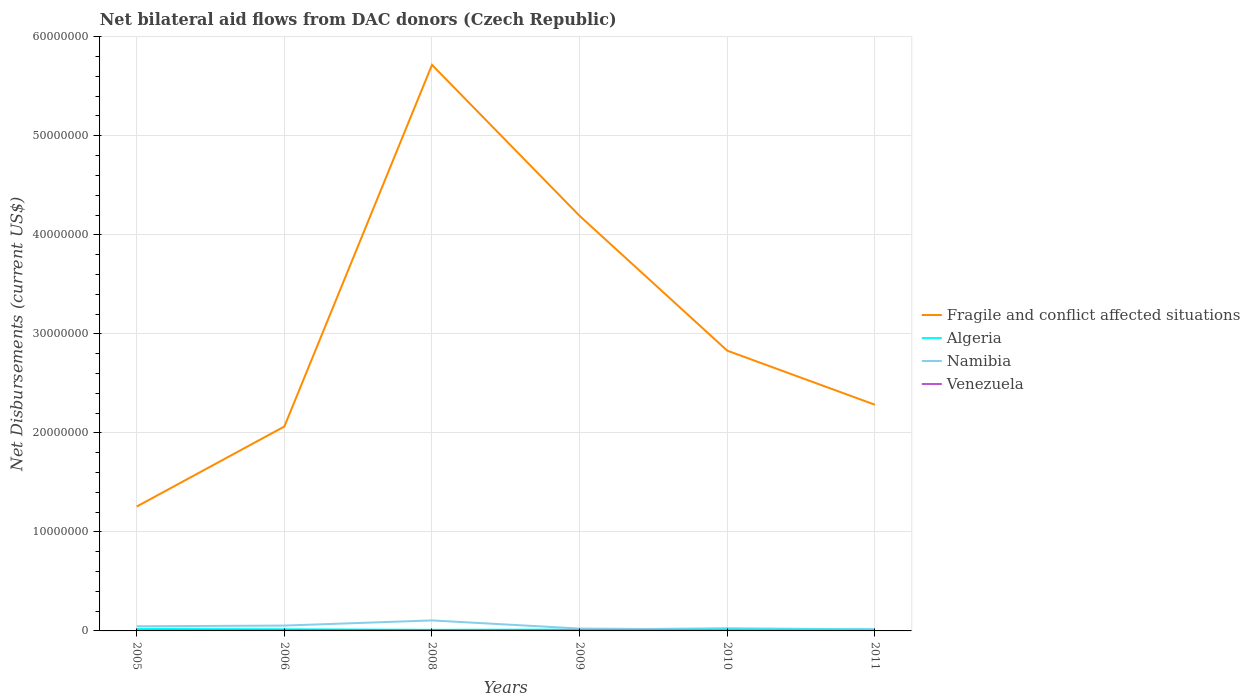How many different coloured lines are there?
Offer a terse response. 4. Across all years, what is the maximum net bilateral aid flows in Namibia?
Ensure brevity in your answer.  1.40e+05. What is the total net bilateral aid flows in Fragile and conflict affected situations in the graph?
Ensure brevity in your answer.  3.43e+07. What is the difference between the highest and the second highest net bilateral aid flows in Fragile and conflict affected situations?
Make the answer very short. 4.46e+07. What is the difference between the highest and the lowest net bilateral aid flows in Algeria?
Your answer should be compact. 2. Is the net bilateral aid flows in Venezuela strictly greater than the net bilateral aid flows in Namibia over the years?
Give a very brief answer. Yes. How many lines are there?
Offer a very short reply. 4. What is the difference between two consecutive major ticks on the Y-axis?
Your answer should be compact. 1.00e+07. Are the values on the major ticks of Y-axis written in scientific E-notation?
Keep it short and to the point. No. Does the graph contain grids?
Provide a short and direct response. Yes. How are the legend labels stacked?
Ensure brevity in your answer.  Vertical. What is the title of the graph?
Make the answer very short. Net bilateral aid flows from DAC donors (Czech Republic). Does "Italy" appear as one of the legend labels in the graph?
Give a very brief answer. No. What is the label or title of the Y-axis?
Give a very brief answer. Net Disbursements (current US$). What is the Net Disbursements (current US$) of Fragile and conflict affected situations in 2005?
Offer a very short reply. 1.26e+07. What is the Net Disbursements (current US$) of Namibia in 2005?
Make the answer very short. 4.70e+05. What is the Net Disbursements (current US$) of Venezuela in 2005?
Provide a short and direct response. 3.00e+04. What is the Net Disbursements (current US$) of Fragile and conflict affected situations in 2006?
Provide a short and direct response. 2.06e+07. What is the Net Disbursements (current US$) of Algeria in 2006?
Make the answer very short. 1.70e+05. What is the Net Disbursements (current US$) of Namibia in 2006?
Ensure brevity in your answer.  5.40e+05. What is the Net Disbursements (current US$) of Venezuela in 2006?
Offer a terse response. 6.00e+04. What is the Net Disbursements (current US$) of Fragile and conflict affected situations in 2008?
Provide a short and direct response. 5.72e+07. What is the Net Disbursements (current US$) in Namibia in 2008?
Keep it short and to the point. 1.06e+06. What is the Net Disbursements (current US$) in Fragile and conflict affected situations in 2009?
Give a very brief answer. 4.19e+07. What is the Net Disbursements (current US$) of Namibia in 2009?
Provide a short and direct response. 2.40e+05. What is the Net Disbursements (current US$) of Fragile and conflict affected situations in 2010?
Offer a very short reply. 2.83e+07. What is the Net Disbursements (current US$) of Fragile and conflict affected situations in 2011?
Offer a terse response. 2.28e+07. What is the Net Disbursements (current US$) of Algeria in 2011?
Make the answer very short. 1.60e+05. Across all years, what is the maximum Net Disbursements (current US$) of Fragile and conflict affected situations?
Your answer should be compact. 5.72e+07. Across all years, what is the maximum Net Disbursements (current US$) in Namibia?
Ensure brevity in your answer.  1.06e+06. Across all years, what is the minimum Net Disbursements (current US$) in Fragile and conflict affected situations?
Your answer should be compact. 1.26e+07. Across all years, what is the minimum Net Disbursements (current US$) in Algeria?
Offer a terse response. 1.10e+05. Across all years, what is the minimum Net Disbursements (current US$) of Namibia?
Give a very brief answer. 1.40e+05. What is the total Net Disbursements (current US$) in Fragile and conflict affected situations in the graph?
Keep it short and to the point. 1.83e+08. What is the total Net Disbursements (current US$) of Algeria in the graph?
Your answer should be compact. 1.04e+06. What is the total Net Disbursements (current US$) of Namibia in the graph?
Give a very brief answer. 2.61e+06. What is the total Net Disbursements (current US$) in Venezuela in the graph?
Offer a terse response. 2.70e+05. What is the difference between the Net Disbursements (current US$) of Fragile and conflict affected situations in 2005 and that in 2006?
Offer a terse response. -8.08e+06. What is the difference between the Net Disbursements (current US$) of Algeria in 2005 and that in 2006?
Ensure brevity in your answer.  3.00e+04. What is the difference between the Net Disbursements (current US$) in Fragile and conflict affected situations in 2005 and that in 2008?
Provide a short and direct response. -4.46e+07. What is the difference between the Net Disbursements (current US$) in Namibia in 2005 and that in 2008?
Your response must be concise. -5.90e+05. What is the difference between the Net Disbursements (current US$) in Venezuela in 2005 and that in 2008?
Provide a short and direct response. -5.00e+04. What is the difference between the Net Disbursements (current US$) of Fragile and conflict affected situations in 2005 and that in 2009?
Make the answer very short. -2.94e+07. What is the difference between the Net Disbursements (current US$) of Venezuela in 2005 and that in 2009?
Ensure brevity in your answer.  -2.00e+04. What is the difference between the Net Disbursements (current US$) of Fragile and conflict affected situations in 2005 and that in 2010?
Offer a very short reply. -1.57e+07. What is the difference between the Net Disbursements (current US$) of Algeria in 2005 and that in 2010?
Offer a terse response. -6.00e+04. What is the difference between the Net Disbursements (current US$) of Fragile and conflict affected situations in 2005 and that in 2011?
Your answer should be very brief. -1.03e+07. What is the difference between the Net Disbursements (current US$) in Algeria in 2005 and that in 2011?
Keep it short and to the point. 4.00e+04. What is the difference between the Net Disbursements (current US$) of Fragile and conflict affected situations in 2006 and that in 2008?
Provide a succinct answer. -3.65e+07. What is the difference between the Net Disbursements (current US$) in Algeria in 2006 and that in 2008?
Keep it short and to the point. 6.00e+04. What is the difference between the Net Disbursements (current US$) of Namibia in 2006 and that in 2008?
Make the answer very short. -5.20e+05. What is the difference between the Net Disbursements (current US$) of Venezuela in 2006 and that in 2008?
Give a very brief answer. -2.00e+04. What is the difference between the Net Disbursements (current US$) of Fragile and conflict affected situations in 2006 and that in 2009?
Provide a short and direct response. -2.13e+07. What is the difference between the Net Disbursements (current US$) in Venezuela in 2006 and that in 2009?
Offer a terse response. 10000. What is the difference between the Net Disbursements (current US$) in Fragile and conflict affected situations in 2006 and that in 2010?
Keep it short and to the point. -7.66e+06. What is the difference between the Net Disbursements (current US$) in Fragile and conflict affected situations in 2006 and that in 2011?
Provide a short and direct response. -2.20e+06. What is the difference between the Net Disbursements (current US$) in Namibia in 2006 and that in 2011?
Provide a short and direct response. 3.80e+05. What is the difference between the Net Disbursements (current US$) in Venezuela in 2006 and that in 2011?
Make the answer very short. 5.00e+04. What is the difference between the Net Disbursements (current US$) of Fragile and conflict affected situations in 2008 and that in 2009?
Provide a succinct answer. 1.52e+07. What is the difference between the Net Disbursements (current US$) of Algeria in 2008 and that in 2009?
Provide a succinct answer. -3.00e+04. What is the difference between the Net Disbursements (current US$) in Namibia in 2008 and that in 2009?
Ensure brevity in your answer.  8.20e+05. What is the difference between the Net Disbursements (current US$) of Venezuela in 2008 and that in 2009?
Provide a short and direct response. 3.00e+04. What is the difference between the Net Disbursements (current US$) of Fragile and conflict affected situations in 2008 and that in 2010?
Ensure brevity in your answer.  2.89e+07. What is the difference between the Net Disbursements (current US$) of Algeria in 2008 and that in 2010?
Keep it short and to the point. -1.50e+05. What is the difference between the Net Disbursements (current US$) of Namibia in 2008 and that in 2010?
Your answer should be compact. 9.20e+05. What is the difference between the Net Disbursements (current US$) of Fragile and conflict affected situations in 2008 and that in 2011?
Provide a succinct answer. 3.43e+07. What is the difference between the Net Disbursements (current US$) of Namibia in 2008 and that in 2011?
Your response must be concise. 9.00e+05. What is the difference between the Net Disbursements (current US$) of Fragile and conflict affected situations in 2009 and that in 2010?
Your answer should be compact. 1.36e+07. What is the difference between the Net Disbursements (current US$) in Namibia in 2009 and that in 2010?
Offer a terse response. 1.00e+05. What is the difference between the Net Disbursements (current US$) in Venezuela in 2009 and that in 2010?
Offer a very short reply. 10000. What is the difference between the Net Disbursements (current US$) of Fragile and conflict affected situations in 2009 and that in 2011?
Ensure brevity in your answer.  1.91e+07. What is the difference between the Net Disbursements (current US$) in Algeria in 2009 and that in 2011?
Offer a terse response. -2.00e+04. What is the difference between the Net Disbursements (current US$) of Fragile and conflict affected situations in 2010 and that in 2011?
Ensure brevity in your answer.  5.46e+06. What is the difference between the Net Disbursements (current US$) of Venezuela in 2010 and that in 2011?
Make the answer very short. 3.00e+04. What is the difference between the Net Disbursements (current US$) in Fragile and conflict affected situations in 2005 and the Net Disbursements (current US$) in Algeria in 2006?
Provide a short and direct response. 1.24e+07. What is the difference between the Net Disbursements (current US$) of Fragile and conflict affected situations in 2005 and the Net Disbursements (current US$) of Namibia in 2006?
Your answer should be very brief. 1.20e+07. What is the difference between the Net Disbursements (current US$) of Fragile and conflict affected situations in 2005 and the Net Disbursements (current US$) of Venezuela in 2006?
Ensure brevity in your answer.  1.25e+07. What is the difference between the Net Disbursements (current US$) of Algeria in 2005 and the Net Disbursements (current US$) of Namibia in 2006?
Ensure brevity in your answer.  -3.40e+05. What is the difference between the Net Disbursements (current US$) in Namibia in 2005 and the Net Disbursements (current US$) in Venezuela in 2006?
Give a very brief answer. 4.10e+05. What is the difference between the Net Disbursements (current US$) of Fragile and conflict affected situations in 2005 and the Net Disbursements (current US$) of Algeria in 2008?
Offer a very short reply. 1.24e+07. What is the difference between the Net Disbursements (current US$) in Fragile and conflict affected situations in 2005 and the Net Disbursements (current US$) in Namibia in 2008?
Make the answer very short. 1.15e+07. What is the difference between the Net Disbursements (current US$) of Fragile and conflict affected situations in 2005 and the Net Disbursements (current US$) of Venezuela in 2008?
Your answer should be compact. 1.25e+07. What is the difference between the Net Disbursements (current US$) in Algeria in 2005 and the Net Disbursements (current US$) in Namibia in 2008?
Your response must be concise. -8.60e+05. What is the difference between the Net Disbursements (current US$) in Namibia in 2005 and the Net Disbursements (current US$) in Venezuela in 2008?
Your response must be concise. 3.90e+05. What is the difference between the Net Disbursements (current US$) in Fragile and conflict affected situations in 2005 and the Net Disbursements (current US$) in Algeria in 2009?
Provide a short and direct response. 1.24e+07. What is the difference between the Net Disbursements (current US$) in Fragile and conflict affected situations in 2005 and the Net Disbursements (current US$) in Namibia in 2009?
Give a very brief answer. 1.23e+07. What is the difference between the Net Disbursements (current US$) of Fragile and conflict affected situations in 2005 and the Net Disbursements (current US$) of Venezuela in 2009?
Provide a succinct answer. 1.25e+07. What is the difference between the Net Disbursements (current US$) in Algeria in 2005 and the Net Disbursements (current US$) in Namibia in 2009?
Your answer should be very brief. -4.00e+04. What is the difference between the Net Disbursements (current US$) of Fragile and conflict affected situations in 2005 and the Net Disbursements (current US$) of Algeria in 2010?
Your answer should be very brief. 1.23e+07. What is the difference between the Net Disbursements (current US$) of Fragile and conflict affected situations in 2005 and the Net Disbursements (current US$) of Namibia in 2010?
Make the answer very short. 1.24e+07. What is the difference between the Net Disbursements (current US$) in Fragile and conflict affected situations in 2005 and the Net Disbursements (current US$) in Venezuela in 2010?
Your answer should be compact. 1.25e+07. What is the difference between the Net Disbursements (current US$) of Algeria in 2005 and the Net Disbursements (current US$) of Venezuela in 2010?
Your answer should be compact. 1.60e+05. What is the difference between the Net Disbursements (current US$) in Namibia in 2005 and the Net Disbursements (current US$) in Venezuela in 2010?
Your answer should be very brief. 4.30e+05. What is the difference between the Net Disbursements (current US$) of Fragile and conflict affected situations in 2005 and the Net Disbursements (current US$) of Algeria in 2011?
Your response must be concise. 1.24e+07. What is the difference between the Net Disbursements (current US$) in Fragile and conflict affected situations in 2005 and the Net Disbursements (current US$) in Namibia in 2011?
Offer a terse response. 1.24e+07. What is the difference between the Net Disbursements (current US$) in Fragile and conflict affected situations in 2005 and the Net Disbursements (current US$) in Venezuela in 2011?
Provide a succinct answer. 1.26e+07. What is the difference between the Net Disbursements (current US$) in Algeria in 2005 and the Net Disbursements (current US$) in Venezuela in 2011?
Your response must be concise. 1.90e+05. What is the difference between the Net Disbursements (current US$) in Fragile and conflict affected situations in 2006 and the Net Disbursements (current US$) in Algeria in 2008?
Your response must be concise. 2.05e+07. What is the difference between the Net Disbursements (current US$) in Fragile and conflict affected situations in 2006 and the Net Disbursements (current US$) in Namibia in 2008?
Provide a succinct answer. 1.96e+07. What is the difference between the Net Disbursements (current US$) of Fragile and conflict affected situations in 2006 and the Net Disbursements (current US$) of Venezuela in 2008?
Your response must be concise. 2.06e+07. What is the difference between the Net Disbursements (current US$) of Algeria in 2006 and the Net Disbursements (current US$) of Namibia in 2008?
Give a very brief answer. -8.90e+05. What is the difference between the Net Disbursements (current US$) in Fragile and conflict affected situations in 2006 and the Net Disbursements (current US$) in Algeria in 2009?
Your answer should be compact. 2.05e+07. What is the difference between the Net Disbursements (current US$) of Fragile and conflict affected situations in 2006 and the Net Disbursements (current US$) of Namibia in 2009?
Your answer should be very brief. 2.04e+07. What is the difference between the Net Disbursements (current US$) in Fragile and conflict affected situations in 2006 and the Net Disbursements (current US$) in Venezuela in 2009?
Give a very brief answer. 2.06e+07. What is the difference between the Net Disbursements (current US$) of Algeria in 2006 and the Net Disbursements (current US$) of Namibia in 2009?
Provide a succinct answer. -7.00e+04. What is the difference between the Net Disbursements (current US$) of Algeria in 2006 and the Net Disbursements (current US$) of Venezuela in 2009?
Your response must be concise. 1.20e+05. What is the difference between the Net Disbursements (current US$) in Namibia in 2006 and the Net Disbursements (current US$) in Venezuela in 2009?
Offer a terse response. 4.90e+05. What is the difference between the Net Disbursements (current US$) of Fragile and conflict affected situations in 2006 and the Net Disbursements (current US$) of Algeria in 2010?
Ensure brevity in your answer.  2.04e+07. What is the difference between the Net Disbursements (current US$) of Fragile and conflict affected situations in 2006 and the Net Disbursements (current US$) of Namibia in 2010?
Keep it short and to the point. 2.05e+07. What is the difference between the Net Disbursements (current US$) of Fragile and conflict affected situations in 2006 and the Net Disbursements (current US$) of Venezuela in 2010?
Keep it short and to the point. 2.06e+07. What is the difference between the Net Disbursements (current US$) in Algeria in 2006 and the Net Disbursements (current US$) in Namibia in 2010?
Provide a succinct answer. 3.00e+04. What is the difference between the Net Disbursements (current US$) of Algeria in 2006 and the Net Disbursements (current US$) of Venezuela in 2010?
Ensure brevity in your answer.  1.30e+05. What is the difference between the Net Disbursements (current US$) of Fragile and conflict affected situations in 2006 and the Net Disbursements (current US$) of Algeria in 2011?
Your response must be concise. 2.05e+07. What is the difference between the Net Disbursements (current US$) of Fragile and conflict affected situations in 2006 and the Net Disbursements (current US$) of Namibia in 2011?
Provide a succinct answer. 2.05e+07. What is the difference between the Net Disbursements (current US$) in Fragile and conflict affected situations in 2006 and the Net Disbursements (current US$) in Venezuela in 2011?
Your answer should be compact. 2.06e+07. What is the difference between the Net Disbursements (current US$) of Algeria in 2006 and the Net Disbursements (current US$) of Namibia in 2011?
Offer a terse response. 10000. What is the difference between the Net Disbursements (current US$) in Namibia in 2006 and the Net Disbursements (current US$) in Venezuela in 2011?
Ensure brevity in your answer.  5.30e+05. What is the difference between the Net Disbursements (current US$) of Fragile and conflict affected situations in 2008 and the Net Disbursements (current US$) of Algeria in 2009?
Make the answer very short. 5.70e+07. What is the difference between the Net Disbursements (current US$) in Fragile and conflict affected situations in 2008 and the Net Disbursements (current US$) in Namibia in 2009?
Ensure brevity in your answer.  5.69e+07. What is the difference between the Net Disbursements (current US$) in Fragile and conflict affected situations in 2008 and the Net Disbursements (current US$) in Venezuela in 2009?
Provide a short and direct response. 5.71e+07. What is the difference between the Net Disbursements (current US$) of Algeria in 2008 and the Net Disbursements (current US$) of Namibia in 2009?
Make the answer very short. -1.30e+05. What is the difference between the Net Disbursements (current US$) of Namibia in 2008 and the Net Disbursements (current US$) of Venezuela in 2009?
Give a very brief answer. 1.01e+06. What is the difference between the Net Disbursements (current US$) in Fragile and conflict affected situations in 2008 and the Net Disbursements (current US$) in Algeria in 2010?
Ensure brevity in your answer.  5.69e+07. What is the difference between the Net Disbursements (current US$) of Fragile and conflict affected situations in 2008 and the Net Disbursements (current US$) of Namibia in 2010?
Make the answer very short. 5.70e+07. What is the difference between the Net Disbursements (current US$) in Fragile and conflict affected situations in 2008 and the Net Disbursements (current US$) in Venezuela in 2010?
Ensure brevity in your answer.  5.71e+07. What is the difference between the Net Disbursements (current US$) of Algeria in 2008 and the Net Disbursements (current US$) of Venezuela in 2010?
Your answer should be very brief. 7.00e+04. What is the difference between the Net Disbursements (current US$) of Namibia in 2008 and the Net Disbursements (current US$) of Venezuela in 2010?
Ensure brevity in your answer.  1.02e+06. What is the difference between the Net Disbursements (current US$) of Fragile and conflict affected situations in 2008 and the Net Disbursements (current US$) of Algeria in 2011?
Your response must be concise. 5.70e+07. What is the difference between the Net Disbursements (current US$) in Fragile and conflict affected situations in 2008 and the Net Disbursements (current US$) in Namibia in 2011?
Provide a short and direct response. 5.70e+07. What is the difference between the Net Disbursements (current US$) of Fragile and conflict affected situations in 2008 and the Net Disbursements (current US$) of Venezuela in 2011?
Offer a terse response. 5.72e+07. What is the difference between the Net Disbursements (current US$) in Namibia in 2008 and the Net Disbursements (current US$) in Venezuela in 2011?
Provide a succinct answer. 1.05e+06. What is the difference between the Net Disbursements (current US$) in Fragile and conflict affected situations in 2009 and the Net Disbursements (current US$) in Algeria in 2010?
Offer a very short reply. 4.16e+07. What is the difference between the Net Disbursements (current US$) of Fragile and conflict affected situations in 2009 and the Net Disbursements (current US$) of Namibia in 2010?
Provide a short and direct response. 4.18e+07. What is the difference between the Net Disbursements (current US$) of Fragile and conflict affected situations in 2009 and the Net Disbursements (current US$) of Venezuela in 2010?
Provide a short and direct response. 4.19e+07. What is the difference between the Net Disbursements (current US$) of Algeria in 2009 and the Net Disbursements (current US$) of Namibia in 2010?
Offer a very short reply. 0. What is the difference between the Net Disbursements (current US$) of Fragile and conflict affected situations in 2009 and the Net Disbursements (current US$) of Algeria in 2011?
Provide a short and direct response. 4.18e+07. What is the difference between the Net Disbursements (current US$) of Fragile and conflict affected situations in 2009 and the Net Disbursements (current US$) of Namibia in 2011?
Your response must be concise. 4.18e+07. What is the difference between the Net Disbursements (current US$) in Fragile and conflict affected situations in 2009 and the Net Disbursements (current US$) in Venezuela in 2011?
Ensure brevity in your answer.  4.19e+07. What is the difference between the Net Disbursements (current US$) in Algeria in 2009 and the Net Disbursements (current US$) in Namibia in 2011?
Your answer should be compact. -2.00e+04. What is the difference between the Net Disbursements (current US$) in Fragile and conflict affected situations in 2010 and the Net Disbursements (current US$) in Algeria in 2011?
Keep it short and to the point. 2.81e+07. What is the difference between the Net Disbursements (current US$) in Fragile and conflict affected situations in 2010 and the Net Disbursements (current US$) in Namibia in 2011?
Your answer should be very brief. 2.81e+07. What is the difference between the Net Disbursements (current US$) of Fragile and conflict affected situations in 2010 and the Net Disbursements (current US$) of Venezuela in 2011?
Give a very brief answer. 2.83e+07. What is the difference between the Net Disbursements (current US$) of Algeria in 2010 and the Net Disbursements (current US$) of Namibia in 2011?
Your answer should be very brief. 1.00e+05. What is the difference between the Net Disbursements (current US$) of Algeria in 2010 and the Net Disbursements (current US$) of Venezuela in 2011?
Provide a short and direct response. 2.50e+05. What is the average Net Disbursements (current US$) of Fragile and conflict affected situations per year?
Make the answer very short. 3.06e+07. What is the average Net Disbursements (current US$) of Algeria per year?
Offer a very short reply. 1.73e+05. What is the average Net Disbursements (current US$) in Namibia per year?
Provide a short and direct response. 4.35e+05. What is the average Net Disbursements (current US$) of Venezuela per year?
Ensure brevity in your answer.  4.50e+04. In the year 2005, what is the difference between the Net Disbursements (current US$) of Fragile and conflict affected situations and Net Disbursements (current US$) of Algeria?
Your response must be concise. 1.24e+07. In the year 2005, what is the difference between the Net Disbursements (current US$) of Fragile and conflict affected situations and Net Disbursements (current US$) of Namibia?
Give a very brief answer. 1.21e+07. In the year 2005, what is the difference between the Net Disbursements (current US$) in Fragile and conflict affected situations and Net Disbursements (current US$) in Venezuela?
Give a very brief answer. 1.25e+07. In the year 2005, what is the difference between the Net Disbursements (current US$) of Algeria and Net Disbursements (current US$) of Venezuela?
Make the answer very short. 1.70e+05. In the year 2005, what is the difference between the Net Disbursements (current US$) in Namibia and Net Disbursements (current US$) in Venezuela?
Provide a succinct answer. 4.40e+05. In the year 2006, what is the difference between the Net Disbursements (current US$) of Fragile and conflict affected situations and Net Disbursements (current US$) of Algeria?
Your answer should be very brief. 2.05e+07. In the year 2006, what is the difference between the Net Disbursements (current US$) of Fragile and conflict affected situations and Net Disbursements (current US$) of Namibia?
Ensure brevity in your answer.  2.01e+07. In the year 2006, what is the difference between the Net Disbursements (current US$) of Fragile and conflict affected situations and Net Disbursements (current US$) of Venezuela?
Your answer should be very brief. 2.06e+07. In the year 2006, what is the difference between the Net Disbursements (current US$) in Algeria and Net Disbursements (current US$) in Namibia?
Offer a terse response. -3.70e+05. In the year 2006, what is the difference between the Net Disbursements (current US$) in Algeria and Net Disbursements (current US$) in Venezuela?
Make the answer very short. 1.10e+05. In the year 2008, what is the difference between the Net Disbursements (current US$) of Fragile and conflict affected situations and Net Disbursements (current US$) of Algeria?
Ensure brevity in your answer.  5.70e+07. In the year 2008, what is the difference between the Net Disbursements (current US$) of Fragile and conflict affected situations and Net Disbursements (current US$) of Namibia?
Make the answer very short. 5.61e+07. In the year 2008, what is the difference between the Net Disbursements (current US$) in Fragile and conflict affected situations and Net Disbursements (current US$) in Venezuela?
Your response must be concise. 5.71e+07. In the year 2008, what is the difference between the Net Disbursements (current US$) of Algeria and Net Disbursements (current US$) of Namibia?
Give a very brief answer. -9.50e+05. In the year 2008, what is the difference between the Net Disbursements (current US$) of Namibia and Net Disbursements (current US$) of Venezuela?
Give a very brief answer. 9.80e+05. In the year 2009, what is the difference between the Net Disbursements (current US$) in Fragile and conflict affected situations and Net Disbursements (current US$) in Algeria?
Give a very brief answer. 4.18e+07. In the year 2009, what is the difference between the Net Disbursements (current US$) of Fragile and conflict affected situations and Net Disbursements (current US$) of Namibia?
Keep it short and to the point. 4.17e+07. In the year 2009, what is the difference between the Net Disbursements (current US$) of Fragile and conflict affected situations and Net Disbursements (current US$) of Venezuela?
Give a very brief answer. 4.19e+07. In the year 2009, what is the difference between the Net Disbursements (current US$) in Namibia and Net Disbursements (current US$) in Venezuela?
Your answer should be very brief. 1.90e+05. In the year 2010, what is the difference between the Net Disbursements (current US$) of Fragile and conflict affected situations and Net Disbursements (current US$) of Algeria?
Your response must be concise. 2.80e+07. In the year 2010, what is the difference between the Net Disbursements (current US$) in Fragile and conflict affected situations and Net Disbursements (current US$) in Namibia?
Provide a short and direct response. 2.82e+07. In the year 2010, what is the difference between the Net Disbursements (current US$) in Fragile and conflict affected situations and Net Disbursements (current US$) in Venezuela?
Ensure brevity in your answer.  2.83e+07. In the year 2010, what is the difference between the Net Disbursements (current US$) in Algeria and Net Disbursements (current US$) in Venezuela?
Make the answer very short. 2.20e+05. In the year 2011, what is the difference between the Net Disbursements (current US$) in Fragile and conflict affected situations and Net Disbursements (current US$) in Algeria?
Your answer should be very brief. 2.27e+07. In the year 2011, what is the difference between the Net Disbursements (current US$) in Fragile and conflict affected situations and Net Disbursements (current US$) in Namibia?
Your answer should be compact. 2.27e+07. In the year 2011, what is the difference between the Net Disbursements (current US$) of Fragile and conflict affected situations and Net Disbursements (current US$) of Venezuela?
Keep it short and to the point. 2.28e+07. What is the ratio of the Net Disbursements (current US$) in Fragile and conflict affected situations in 2005 to that in 2006?
Keep it short and to the point. 0.61. What is the ratio of the Net Disbursements (current US$) in Algeria in 2005 to that in 2006?
Keep it short and to the point. 1.18. What is the ratio of the Net Disbursements (current US$) in Namibia in 2005 to that in 2006?
Offer a very short reply. 0.87. What is the ratio of the Net Disbursements (current US$) of Venezuela in 2005 to that in 2006?
Your response must be concise. 0.5. What is the ratio of the Net Disbursements (current US$) of Fragile and conflict affected situations in 2005 to that in 2008?
Ensure brevity in your answer.  0.22. What is the ratio of the Net Disbursements (current US$) of Algeria in 2005 to that in 2008?
Your answer should be compact. 1.82. What is the ratio of the Net Disbursements (current US$) in Namibia in 2005 to that in 2008?
Your response must be concise. 0.44. What is the ratio of the Net Disbursements (current US$) in Venezuela in 2005 to that in 2008?
Keep it short and to the point. 0.38. What is the ratio of the Net Disbursements (current US$) in Fragile and conflict affected situations in 2005 to that in 2009?
Provide a short and direct response. 0.3. What is the ratio of the Net Disbursements (current US$) in Algeria in 2005 to that in 2009?
Keep it short and to the point. 1.43. What is the ratio of the Net Disbursements (current US$) in Namibia in 2005 to that in 2009?
Your response must be concise. 1.96. What is the ratio of the Net Disbursements (current US$) in Venezuela in 2005 to that in 2009?
Your answer should be compact. 0.6. What is the ratio of the Net Disbursements (current US$) in Fragile and conflict affected situations in 2005 to that in 2010?
Your response must be concise. 0.44. What is the ratio of the Net Disbursements (current US$) of Algeria in 2005 to that in 2010?
Offer a very short reply. 0.77. What is the ratio of the Net Disbursements (current US$) in Namibia in 2005 to that in 2010?
Ensure brevity in your answer.  3.36. What is the ratio of the Net Disbursements (current US$) of Fragile and conflict affected situations in 2005 to that in 2011?
Offer a terse response. 0.55. What is the ratio of the Net Disbursements (current US$) in Algeria in 2005 to that in 2011?
Provide a succinct answer. 1.25. What is the ratio of the Net Disbursements (current US$) of Namibia in 2005 to that in 2011?
Ensure brevity in your answer.  2.94. What is the ratio of the Net Disbursements (current US$) in Venezuela in 2005 to that in 2011?
Make the answer very short. 3. What is the ratio of the Net Disbursements (current US$) of Fragile and conflict affected situations in 2006 to that in 2008?
Offer a terse response. 0.36. What is the ratio of the Net Disbursements (current US$) in Algeria in 2006 to that in 2008?
Make the answer very short. 1.55. What is the ratio of the Net Disbursements (current US$) of Namibia in 2006 to that in 2008?
Offer a very short reply. 0.51. What is the ratio of the Net Disbursements (current US$) of Venezuela in 2006 to that in 2008?
Offer a very short reply. 0.75. What is the ratio of the Net Disbursements (current US$) in Fragile and conflict affected situations in 2006 to that in 2009?
Your response must be concise. 0.49. What is the ratio of the Net Disbursements (current US$) in Algeria in 2006 to that in 2009?
Your answer should be very brief. 1.21. What is the ratio of the Net Disbursements (current US$) in Namibia in 2006 to that in 2009?
Your answer should be compact. 2.25. What is the ratio of the Net Disbursements (current US$) of Fragile and conflict affected situations in 2006 to that in 2010?
Offer a very short reply. 0.73. What is the ratio of the Net Disbursements (current US$) in Algeria in 2006 to that in 2010?
Ensure brevity in your answer.  0.65. What is the ratio of the Net Disbursements (current US$) in Namibia in 2006 to that in 2010?
Provide a short and direct response. 3.86. What is the ratio of the Net Disbursements (current US$) of Venezuela in 2006 to that in 2010?
Your response must be concise. 1.5. What is the ratio of the Net Disbursements (current US$) in Fragile and conflict affected situations in 2006 to that in 2011?
Your answer should be compact. 0.9. What is the ratio of the Net Disbursements (current US$) in Algeria in 2006 to that in 2011?
Provide a short and direct response. 1.06. What is the ratio of the Net Disbursements (current US$) in Namibia in 2006 to that in 2011?
Provide a succinct answer. 3.38. What is the ratio of the Net Disbursements (current US$) in Venezuela in 2006 to that in 2011?
Make the answer very short. 6. What is the ratio of the Net Disbursements (current US$) in Fragile and conflict affected situations in 2008 to that in 2009?
Your response must be concise. 1.36. What is the ratio of the Net Disbursements (current US$) in Algeria in 2008 to that in 2009?
Provide a short and direct response. 0.79. What is the ratio of the Net Disbursements (current US$) of Namibia in 2008 to that in 2009?
Ensure brevity in your answer.  4.42. What is the ratio of the Net Disbursements (current US$) in Fragile and conflict affected situations in 2008 to that in 2010?
Your answer should be compact. 2.02. What is the ratio of the Net Disbursements (current US$) of Algeria in 2008 to that in 2010?
Your response must be concise. 0.42. What is the ratio of the Net Disbursements (current US$) in Namibia in 2008 to that in 2010?
Provide a short and direct response. 7.57. What is the ratio of the Net Disbursements (current US$) of Fragile and conflict affected situations in 2008 to that in 2011?
Your response must be concise. 2.5. What is the ratio of the Net Disbursements (current US$) in Algeria in 2008 to that in 2011?
Ensure brevity in your answer.  0.69. What is the ratio of the Net Disbursements (current US$) in Namibia in 2008 to that in 2011?
Your answer should be very brief. 6.62. What is the ratio of the Net Disbursements (current US$) of Fragile and conflict affected situations in 2009 to that in 2010?
Your answer should be very brief. 1.48. What is the ratio of the Net Disbursements (current US$) of Algeria in 2009 to that in 2010?
Give a very brief answer. 0.54. What is the ratio of the Net Disbursements (current US$) in Namibia in 2009 to that in 2010?
Provide a short and direct response. 1.71. What is the ratio of the Net Disbursements (current US$) of Venezuela in 2009 to that in 2010?
Your response must be concise. 1.25. What is the ratio of the Net Disbursements (current US$) in Fragile and conflict affected situations in 2009 to that in 2011?
Provide a short and direct response. 1.83. What is the ratio of the Net Disbursements (current US$) of Algeria in 2009 to that in 2011?
Offer a terse response. 0.88. What is the ratio of the Net Disbursements (current US$) in Venezuela in 2009 to that in 2011?
Ensure brevity in your answer.  5. What is the ratio of the Net Disbursements (current US$) in Fragile and conflict affected situations in 2010 to that in 2011?
Ensure brevity in your answer.  1.24. What is the ratio of the Net Disbursements (current US$) in Algeria in 2010 to that in 2011?
Provide a succinct answer. 1.62. What is the difference between the highest and the second highest Net Disbursements (current US$) in Fragile and conflict affected situations?
Offer a terse response. 1.52e+07. What is the difference between the highest and the second highest Net Disbursements (current US$) of Namibia?
Keep it short and to the point. 5.20e+05. What is the difference between the highest and the second highest Net Disbursements (current US$) in Venezuela?
Make the answer very short. 2.00e+04. What is the difference between the highest and the lowest Net Disbursements (current US$) of Fragile and conflict affected situations?
Provide a succinct answer. 4.46e+07. What is the difference between the highest and the lowest Net Disbursements (current US$) in Algeria?
Your answer should be very brief. 1.50e+05. What is the difference between the highest and the lowest Net Disbursements (current US$) in Namibia?
Your answer should be compact. 9.20e+05. 